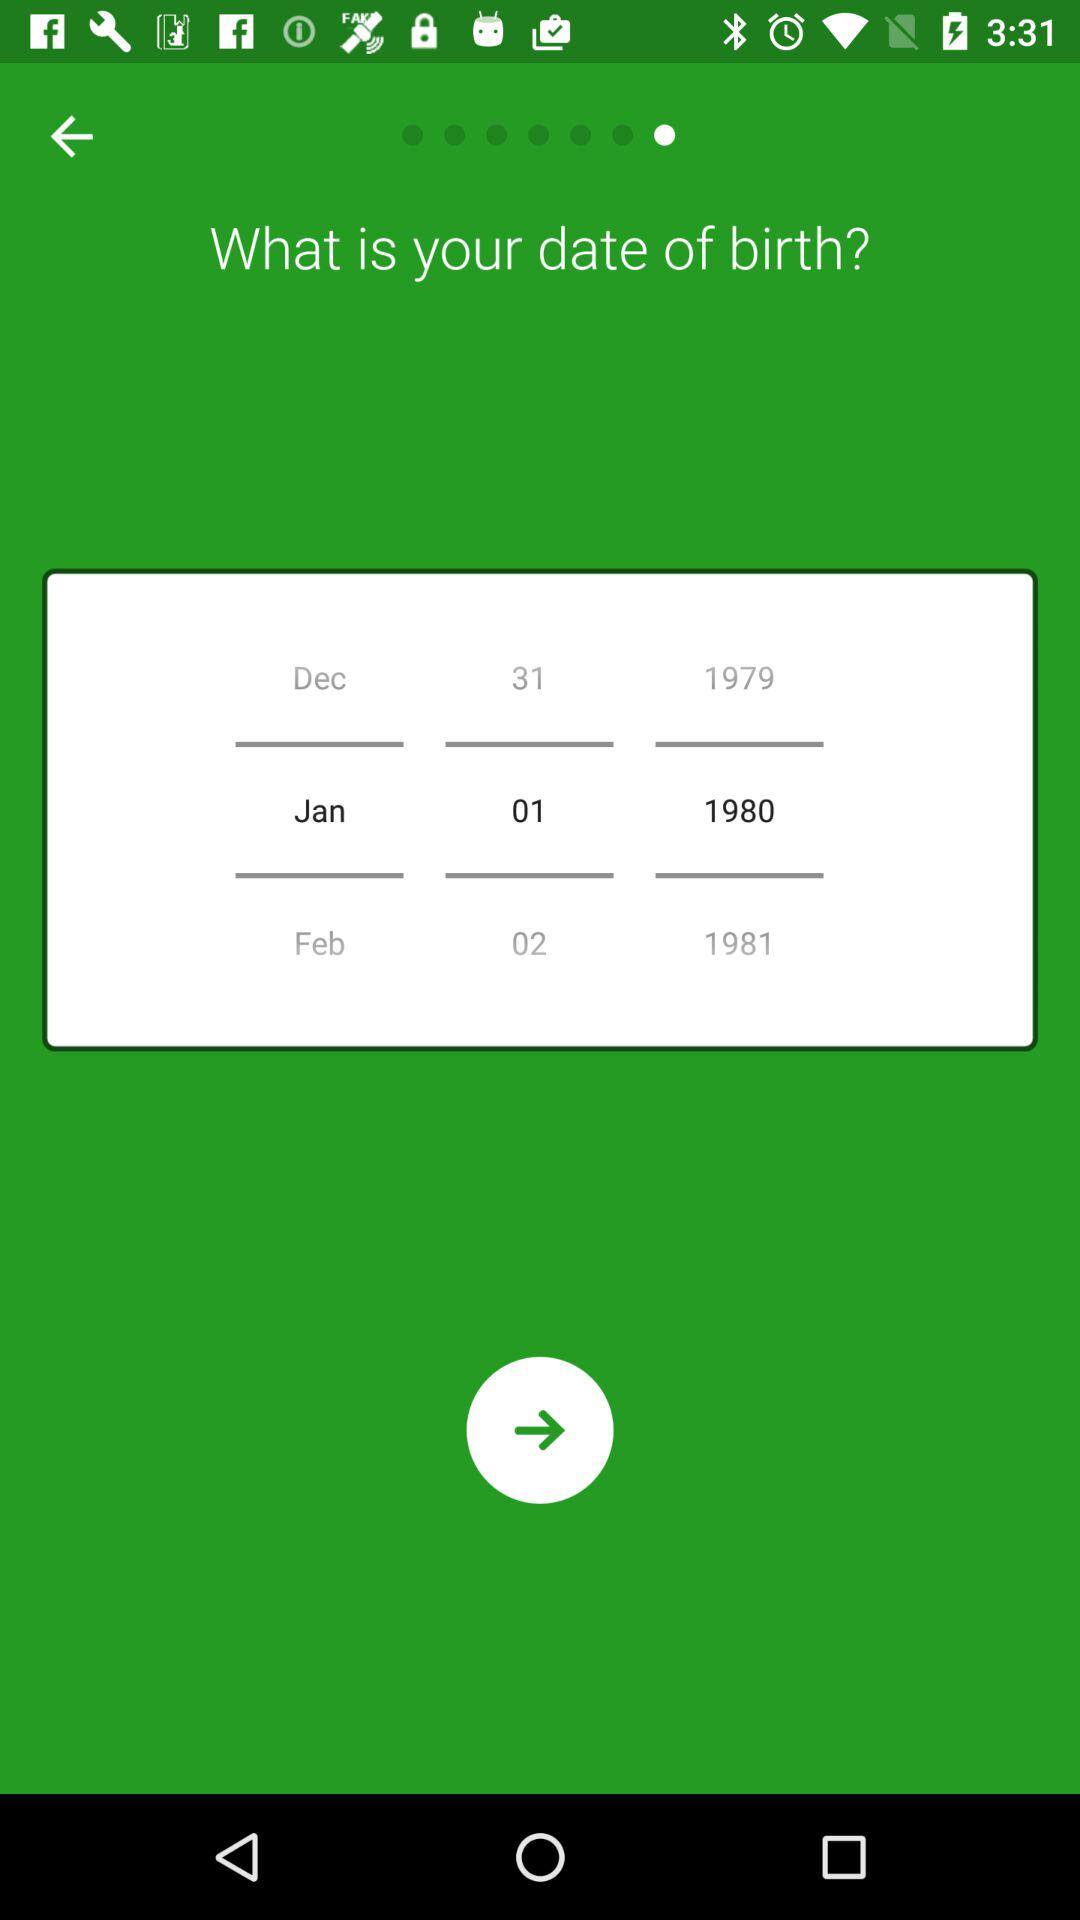Which date is highlighted? The highlighted date is January 1, 1980. 